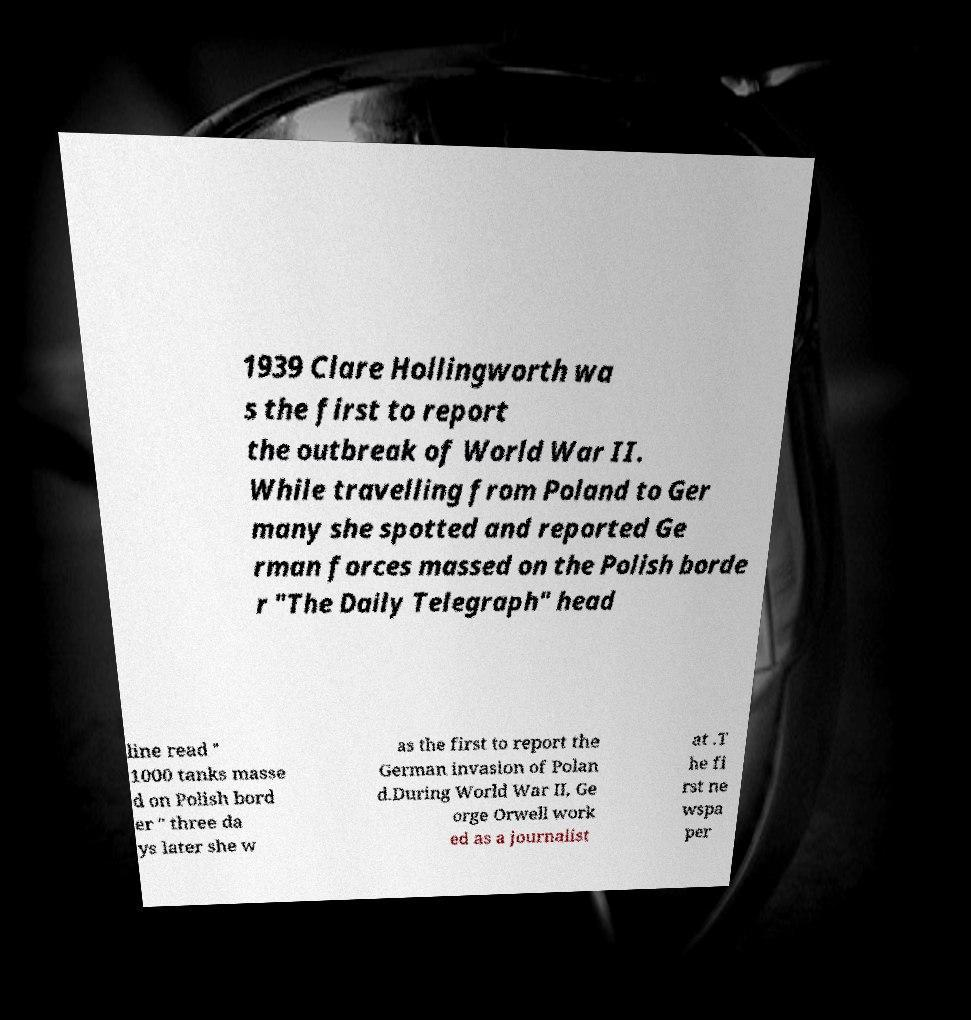For documentation purposes, I need the text within this image transcribed. Could you provide that? 1939 Clare Hollingworth wa s the first to report the outbreak of World War II. While travelling from Poland to Ger many she spotted and reported Ge rman forces massed on the Polish borde r "The Daily Telegraph" head line read " 1000 tanks masse d on Polish bord er " three da ys later she w as the first to report the German invasion of Polan d.During World War II, Ge orge Orwell work ed as a journalist at .T he fi rst ne wspa per 